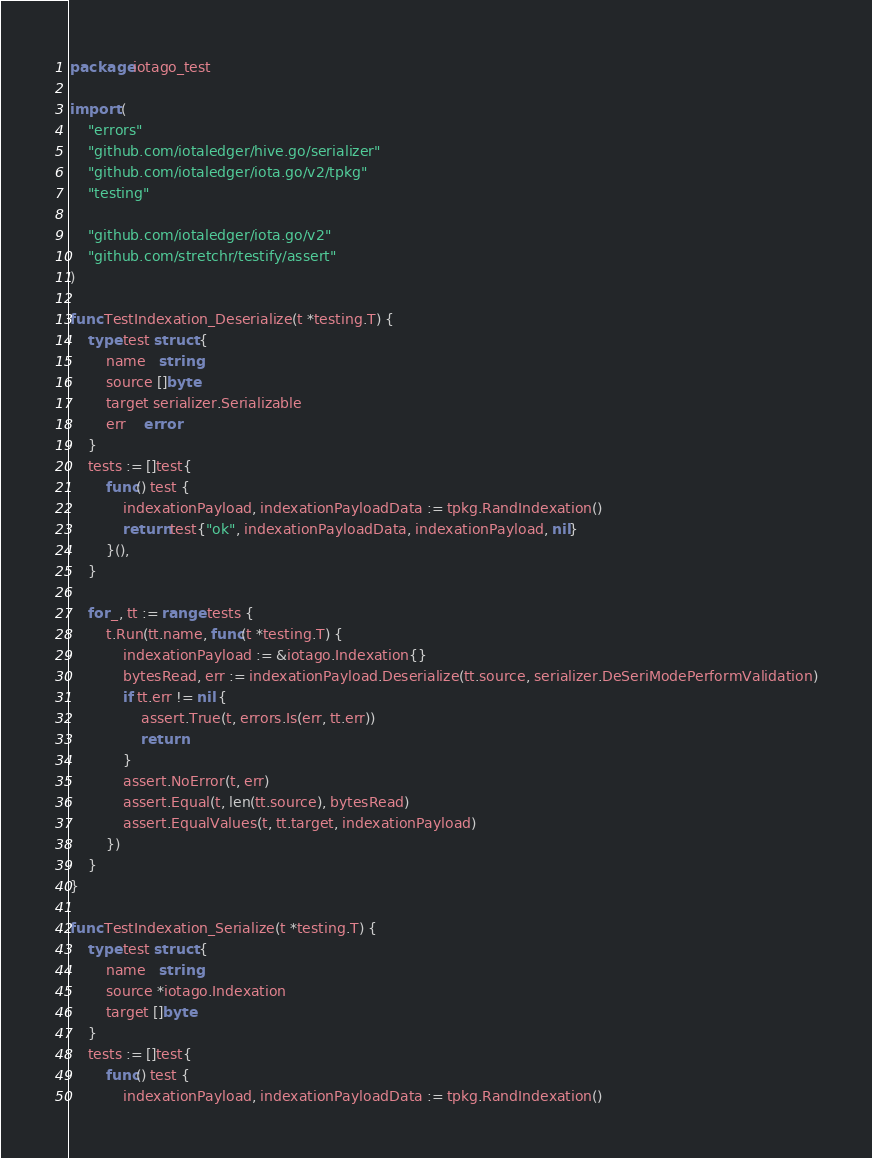<code> <loc_0><loc_0><loc_500><loc_500><_Go_>package iotago_test

import (
	"errors"
	"github.com/iotaledger/hive.go/serializer"
	"github.com/iotaledger/iota.go/v2/tpkg"
	"testing"

	"github.com/iotaledger/iota.go/v2"
	"github.com/stretchr/testify/assert"
)

func TestIndexation_Deserialize(t *testing.T) {
	type test struct {
		name   string
		source []byte
		target serializer.Serializable
		err    error
	}
	tests := []test{
		func() test {
			indexationPayload, indexationPayloadData := tpkg.RandIndexation()
			return test{"ok", indexationPayloadData, indexationPayload, nil}
		}(),
	}

	for _, tt := range tests {
		t.Run(tt.name, func(t *testing.T) {
			indexationPayload := &iotago.Indexation{}
			bytesRead, err := indexationPayload.Deserialize(tt.source, serializer.DeSeriModePerformValidation)
			if tt.err != nil {
				assert.True(t, errors.Is(err, tt.err))
				return
			}
			assert.NoError(t, err)
			assert.Equal(t, len(tt.source), bytesRead)
			assert.EqualValues(t, tt.target, indexationPayload)
		})
	}
}

func TestIndexation_Serialize(t *testing.T) {
	type test struct {
		name   string
		source *iotago.Indexation
		target []byte
	}
	tests := []test{
		func() test {
			indexationPayload, indexationPayloadData := tpkg.RandIndexation()</code> 